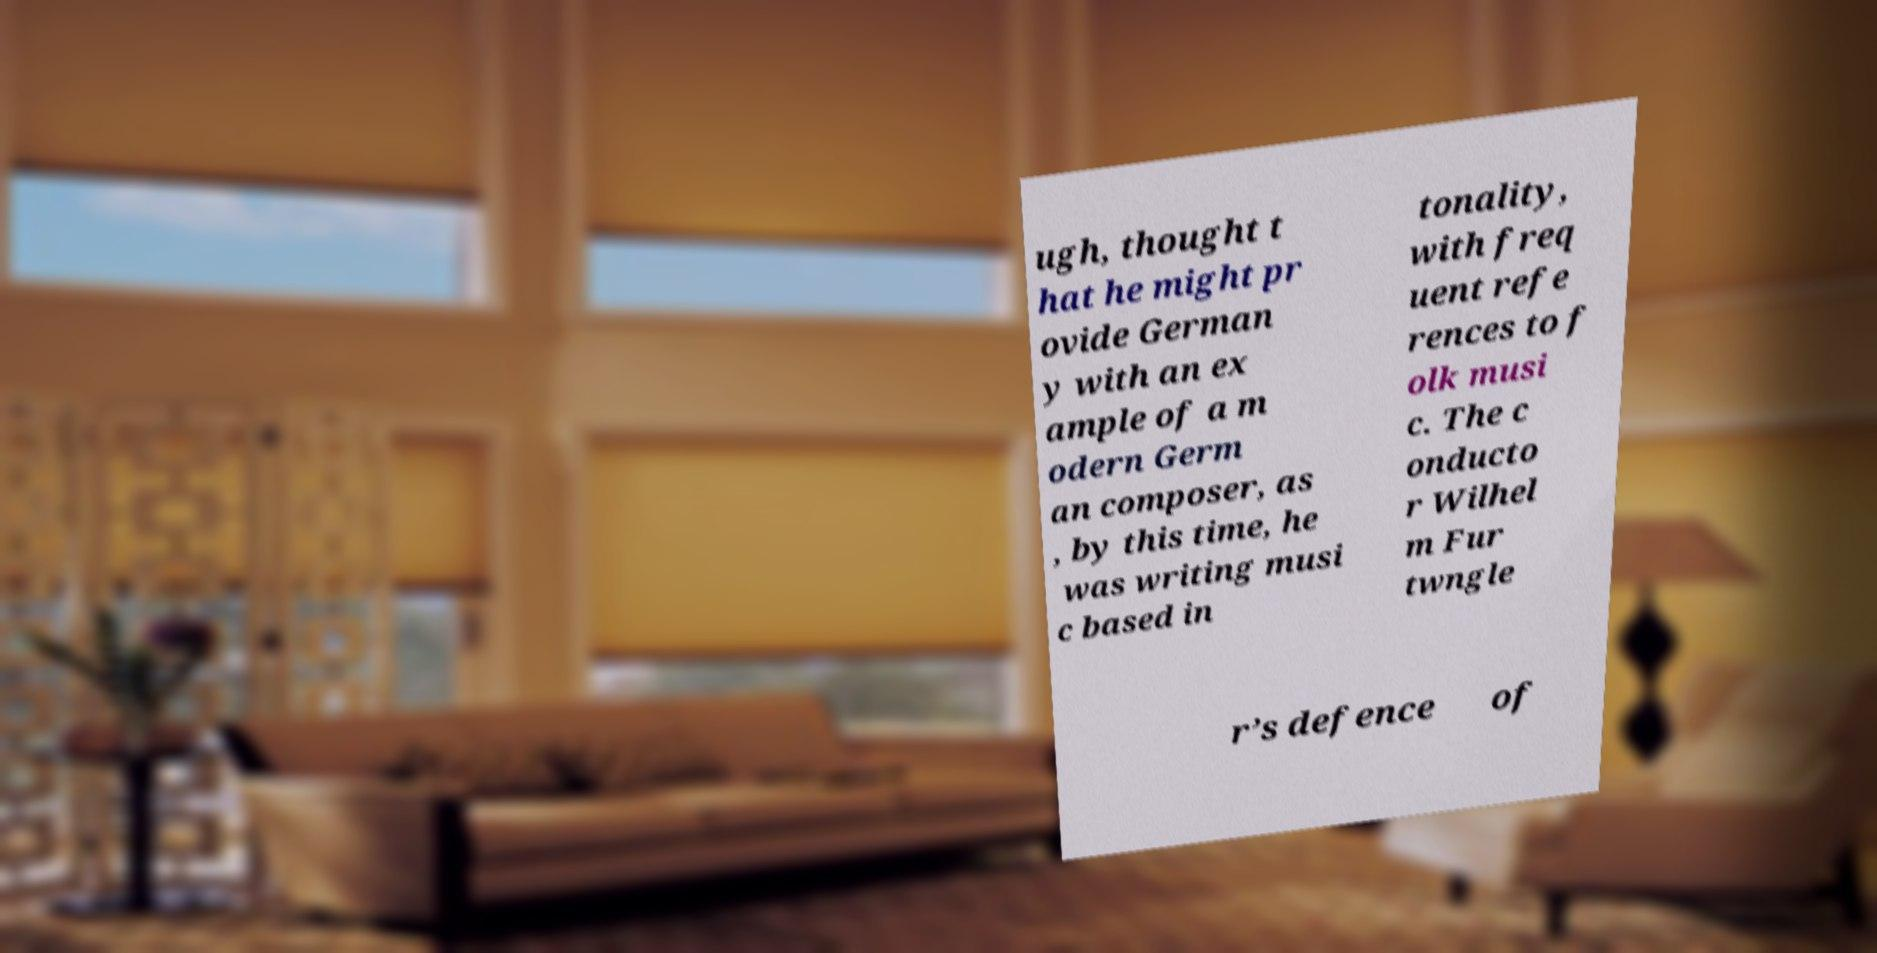What messages or text are displayed in this image? I need them in a readable, typed format. ugh, thought t hat he might pr ovide German y with an ex ample of a m odern Germ an composer, as , by this time, he was writing musi c based in tonality, with freq uent refe rences to f olk musi c. The c onducto r Wilhel m Fur twngle r’s defence of 